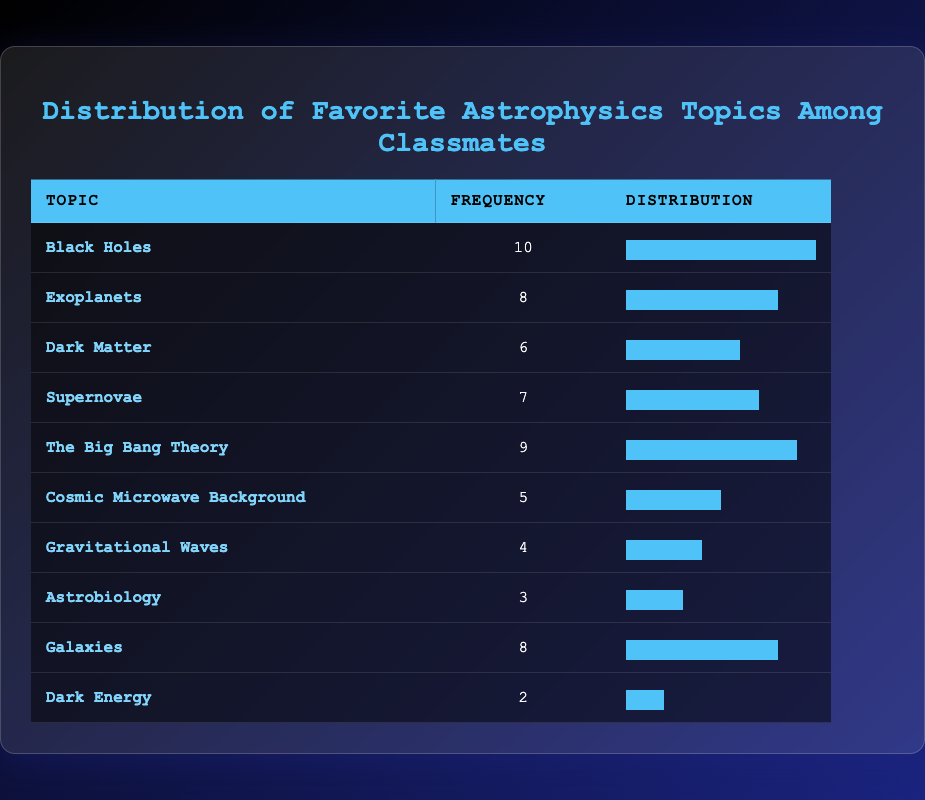What is the most popular astrophysics topic among classmates? Looking at the frequency column, "Black Holes" has the highest frequency of 10, meaning it is the most favored topic.
Answer: Black Holes How many classmates liked "Exoplanets" and "Galaxies" combined? The frequency for "Exoplanets" is 8 and for "Galaxies" is also 8. Adding these together: 8 + 8 = 16.
Answer: 16 Is it true that more classmates prefer "Dark Matter" than "Dark Energy"? The frequency of "Dark Matter" is 6, while "Dark Energy" is 2. Since 6 is greater than 2, it is true.
Answer: Yes What is the average frequency of the topics listed in the table? To find the average, sum the frequencies: 10 + 8 + 6 + 7 + 9 + 5 + 4 + 3 + 8 + 2 = 62. There are 10 topics, so the average is 62/10 = 6.2.
Answer: 6.2 How many topics have a frequency of 7 or higher? The topics with a frequency of 7 or higher are "Black Holes" (10), "Exoplanets" (8), "Supernovae" (7), "The Big Bang Theory" (9), "Galaxies" (8). There are 5 such topics.
Answer: 5 Which topic has the lowest frequency? By reviewing the frequency column, "Dark Energy" has the lowest frequency at 2, meaning it is the least favored topic.
Answer: Dark Energy What is the difference between the frequency of "Supernovae" and "Cosmic Microwave Background"? The frequency of "Supernovae" is 7, and for "Cosmic Microwave Background," it is 5. The difference is 7 - 5 = 2.
Answer: 2 Which topics have the same frequency of 8? "Exoplanets" and "Galaxies" both have a frequency of 8, indicating they are equally favored among classmates.
Answer: Exoplanets, Galaxies 